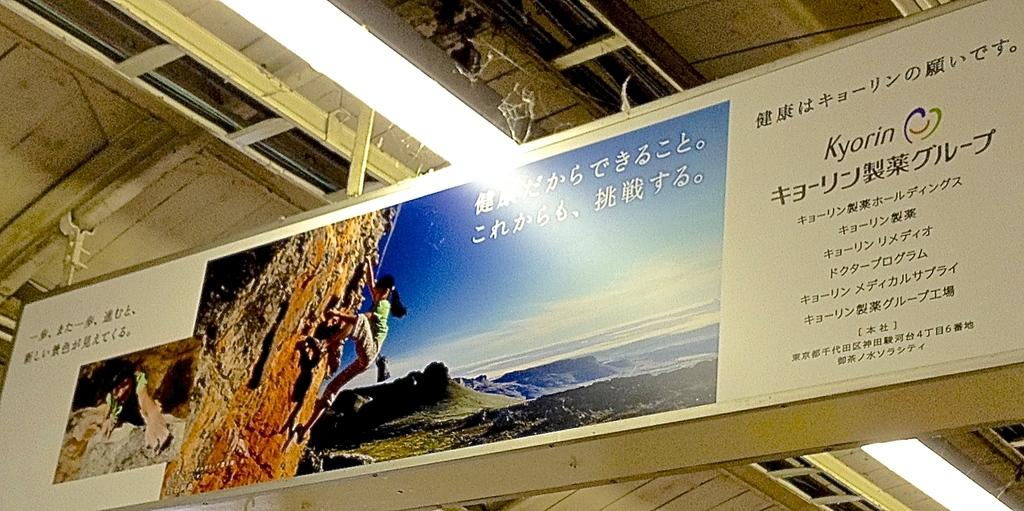<image>
Share a concise interpretation of the image provided. A sign for mountain climbers in Japanese by the company Kyorin 